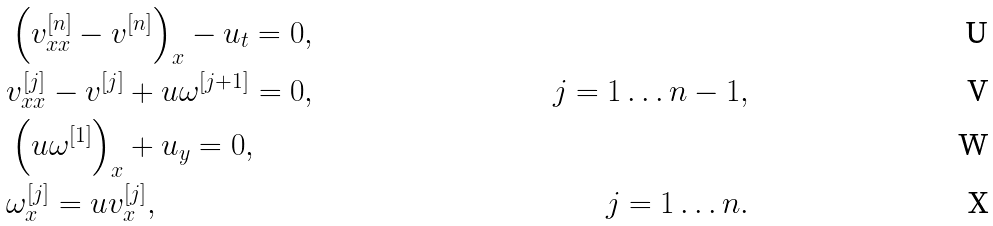Convert formula to latex. <formula><loc_0><loc_0><loc_500><loc_500>& \left ( v _ { x x } ^ { [ n ] } - v ^ { [ n ] } \right ) _ { x } - u _ { t } = 0 , & \\ & v _ { x x } ^ { [ j ] } - v ^ { [ j ] } + u \omega ^ { [ j + 1 ] } = 0 , & j = 1 \dots n - 1 , \\ & \left ( u \omega ^ { [ 1 ] } \right ) _ { x } + u _ { y } = 0 , & \\ & \omega _ { x } ^ { [ j ] } = u v _ { x } ^ { [ j ] } , & j = 1 \dots n .</formula> 